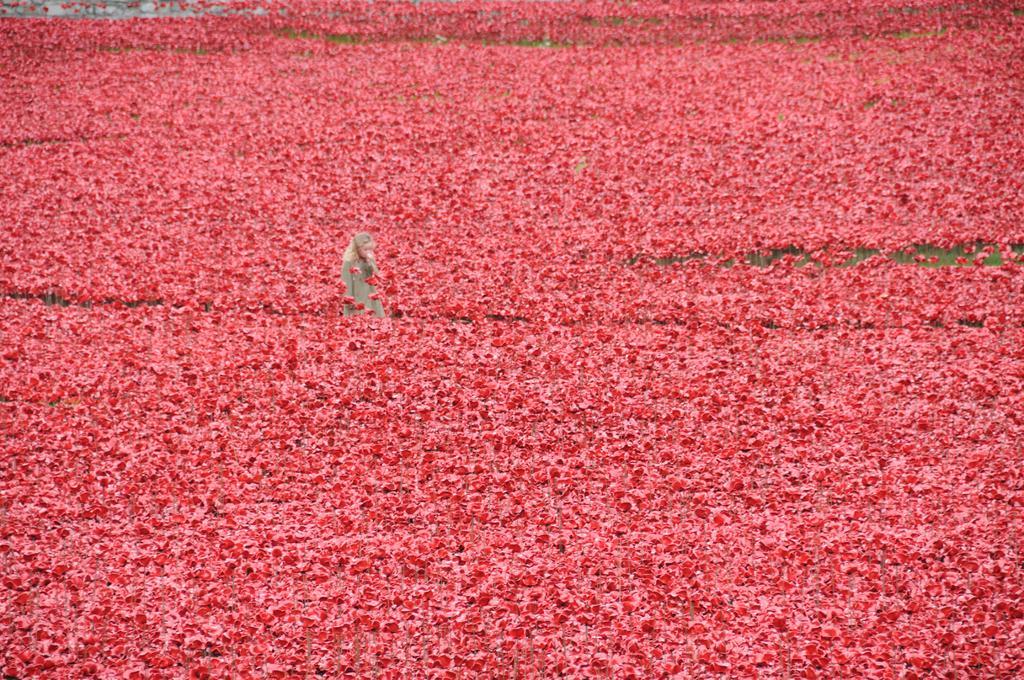Describe this image in one or two sentences. In this image there is a person standing in between the plants. Plants are having red color flowers. 